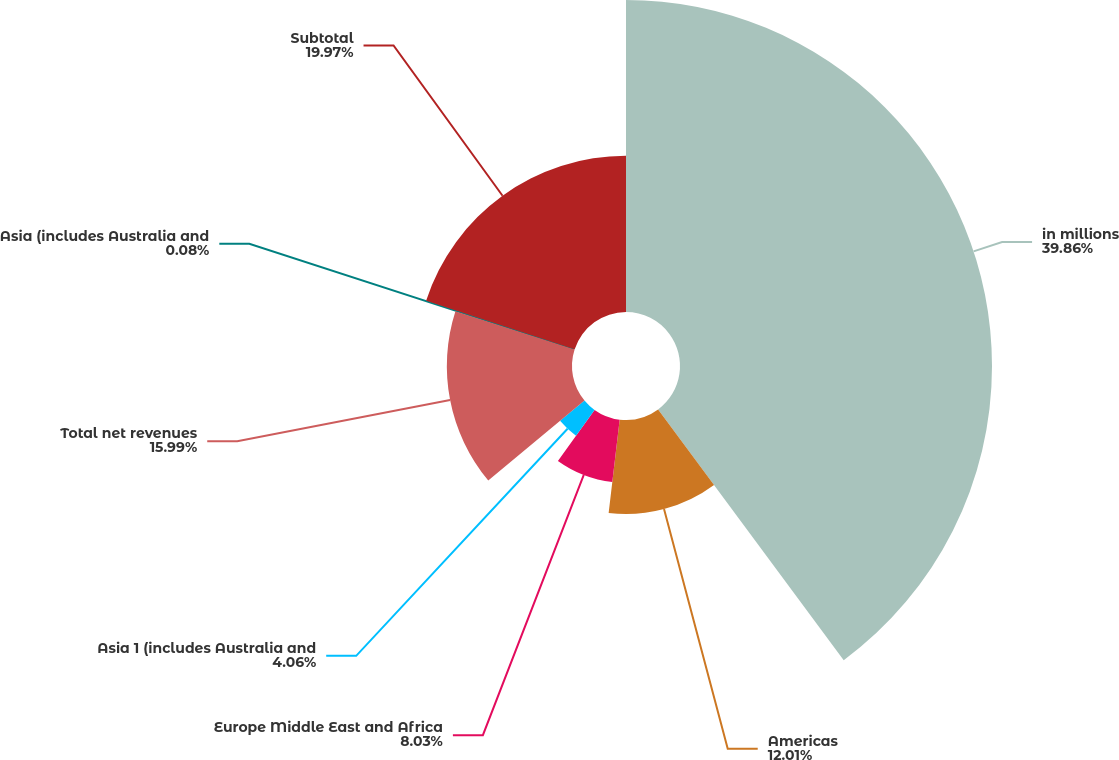<chart> <loc_0><loc_0><loc_500><loc_500><pie_chart><fcel>in millions<fcel>Americas<fcel>Europe Middle East and Africa<fcel>Asia 1 (includes Australia and<fcel>Total net revenues<fcel>Asia (includes Australia and<fcel>Subtotal<nl><fcel>39.86%<fcel>12.01%<fcel>8.03%<fcel>4.06%<fcel>15.99%<fcel>0.08%<fcel>19.97%<nl></chart> 